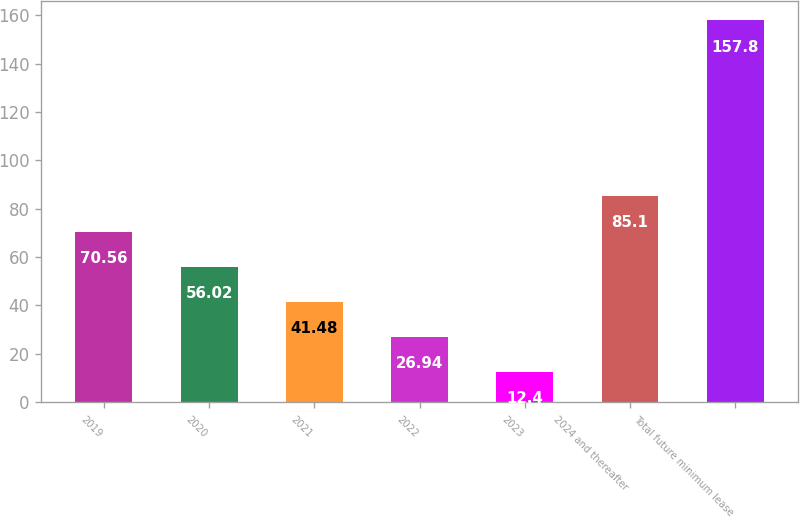Convert chart. <chart><loc_0><loc_0><loc_500><loc_500><bar_chart><fcel>2019<fcel>2020<fcel>2021<fcel>2022<fcel>2023<fcel>2024 and thereafter<fcel>Total future minimum lease<nl><fcel>70.56<fcel>56.02<fcel>41.48<fcel>26.94<fcel>12.4<fcel>85.1<fcel>157.8<nl></chart> 